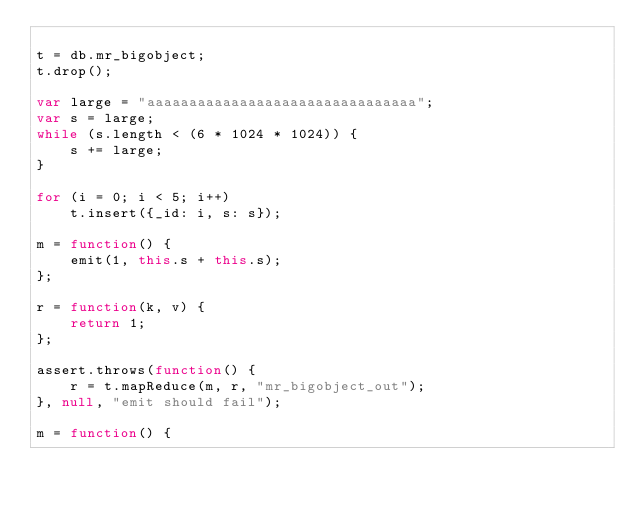<code> <loc_0><loc_0><loc_500><loc_500><_JavaScript_>
t = db.mr_bigobject;
t.drop();

var large = "aaaaaaaaaaaaaaaaaaaaaaaaaaaaaaaa";
var s = large;
while (s.length < (6 * 1024 * 1024)) {
    s += large;
}

for (i = 0; i < 5; i++)
    t.insert({_id: i, s: s});

m = function() {
    emit(1, this.s + this.s);
};

r = function(k, v) {
    return 1;
};

assert.throws(function() {
    r = t.mapReduce(m, r, "mr_bigobject_out");
}, null, "emit should fail");

m = function() {</code> 